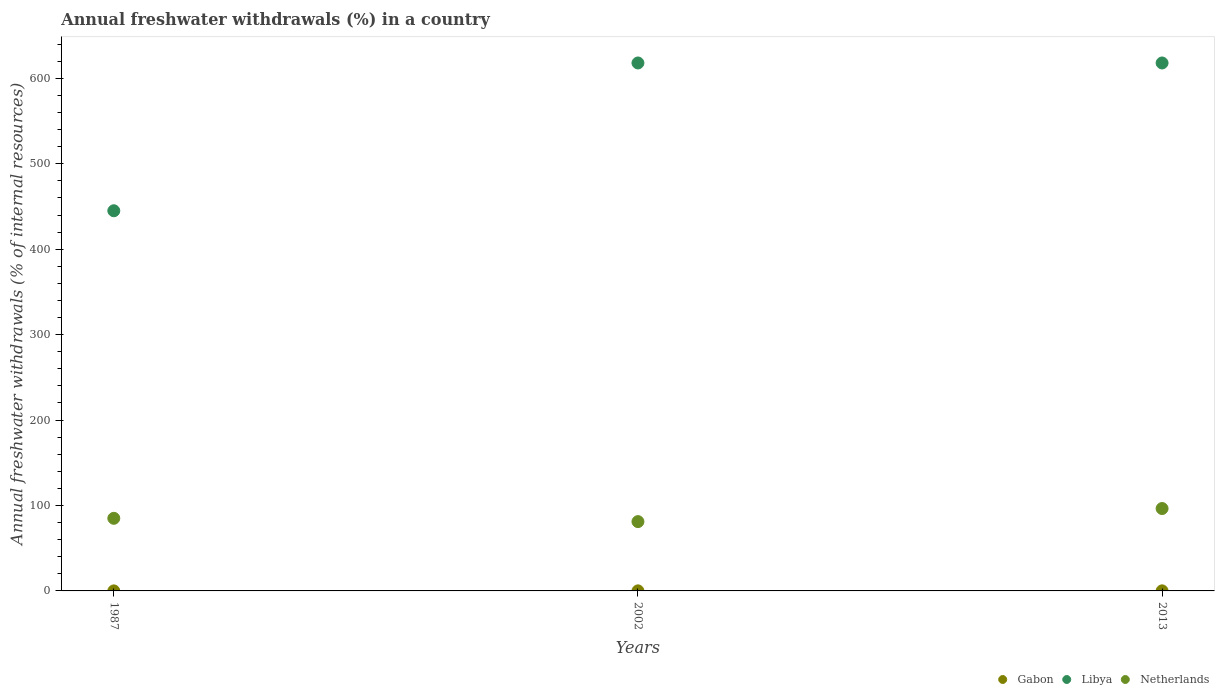Is the number of dotlines equal to the number of legend labels?
Your answer should be very brief. Yes. What is the percentage of annual freshwater withdrawals in Netherlands in 1987?
Keep it short and to the point. 84.99. Across all years, what is the maximum percentage of annual freshwater withdrawals in Libya?
Ensure brevity in your answer.  618. Across all years, what is the minimum percentage of annual freshwater withdrawals in Netherlands?
Ensure brevity in your answer.  81.13. What is the total percentage of annual freshwater withdrawals in Gabon in the graph?
Keep it short and to the point. 0.19. What is the difference between the percentage of annual freshwater withdrawals in Libya in 2013 and the percentage of annual freshwater withdrawals in Netherlands in 1987?
Provide a succinct answer. 533.01. What is the average percentage of annual freshwater withdrawals in Netherlands per year?
Offer a very short reply. 87.52. In the year 1987, what is the difference between the percentage of annual freshwater withdrawals in Gabon and percentage of annual freshwater withdrawals in Netherlands?
Your answer should be very brief. -84.95. What is the ratio of the percentage of annual freshwater withdrawals in Libya in 1987 to that in 2002?
Your answer should be compact. 0.72. What is the difference between the highest and the second highest percentage of annual freshwater withdrawals in Gabon?
Your response must be concise. 0.01. What is the difference between the highest and the lowest percentage of annual freshwater withdrawals in Netherlands?
Your answer should be very brief. 15.33. In how many years, is the percentage of annual freshwater withdrawals in Netherlands greater than the average percentage of annual freshwater withdrawals in Netherlands taken over all years?
Your response must be concise. 1. Is the sum of the percentage of annual freshwater withdrawals in Libya in 1987 and 2002 greater than the maximum percentage of annual freshwater withdrawals in Gabon across all years?
Keep it short and to the point. Yes. Is it the case that in every year, the sum of the percentage of annual freshwater withdrawals in Gabon and percentage of annual freshwater withdrawals in Netherlands  is greater than the percentage of annual freshwater withdrawals in Libya?
Give a very brief answer. No. Does the percentage of annual freshwater withdrawals in Netherlands monotonically increase over the years?
Your answer should be compact. No. How many dotlines are there?
Make the answer very short. 3. How many years are there in the graph?
Your response must be concise. 3. What is the difference between two consecutive major ticks on the Y-axis?
Your answer should be compact. 100. Does the graph contain any zero values?
Offer a terse response. No. Where does the legend appear in the graph?
Make the answer very short. Bottom right. How are the legend labels stacked?
Ensure brevity in your answer.  Horizontal. What is the title of the graph?
Provide a succinct answer. Annual freshwater withdrawals (%) in a country. What is the label or title of the X-axis?
Provide a short and direct response. Years. What is the label or title of the Y-axis?
Offer a terse response. Annual freshwater withdrawals (% of internal resources). What is the Annual freshwater withdrawals (% of internal resources) of Gabon in 1987?
Give a very brief answer. 0.04. What is the Annual freshwater withdrawals (% of internal resources) in Libya in 1987?
Your answer should be compact. 445. What is the Annual freshwater withdrawals (% of internal resources) in Netherlands in 1987?
Offer a very short reply. 84.99. What is the Annual freshwater withdrawals (% of internal resources) in Gabon in 2002?
Offer a very short reply. 0.07. What is the Annual freshwater withdrawals (% of internal resources) in Libya in 2002?
Ensure brevity in your answer.  618. What is the Annual freshwater withdrawals (% of internal resources) in Netherlands in 2002?
Keep it short and to the point. 81.13. What is the Annual freshwater withdrawals (% of internal resources) of Gabon in 2013?
Provide a succinct answer. 0.08. What is the Annual freshwater withdrawals (% of internal resources) in Libya in 2013?
Ensure brevity in your answer.  618. What is the Annual freshwater withdrawals (% of internal resources) of Netherlands in 2013?
Offer a very short reply. 96.45. Across all years, what is the maximum Annual freshwater withdrawals (% of internal resources) of Gabon?
Offer a terse response. 0.08. Across all years, what is the maximum Annual freshwater withdrawals (% of internal resources) of Libya?
Offer a very short reply. 618. Across all years, what is the maximum Annual freshwater withdrawals (% of internal resources) in Netherlands?
Offer a very short reply. 96.45. Across all years, what is the minimum Annual freshwater withdrawals (% of internal resources) of Gabon?
Make the answer very short. 0.04. Across all years, what is the minimum Annual freshwater withdrawals (% of internal resources) in Libya?
Offer a terse response. 445. Across all years, what is the minimum Annual freshwater withdrawals (% of internal resources) of Netherlands?
Provide a succinct answer. 81.13. What is the total Annual freshwater withdrawals (% of internal resources) in Gabon in the graph?
Offer a terse response. 0.19. What is the total Annual freshwater withdrawals (% of internal resources) of Libya in the graph?
Provide a short and direct response. 1681. What is the total Annual freshwater withdrawals (% of internal resources) of Netherlands in the graph?
Your answer should be compact. 262.57. What is the difference between the Annual freshwater withdrawals (% of internal resources) of Gabon in 1987 and that in 2002?
Provide a short and direct response. -0.04. What is the difference between the Annual freshwater withdrawals (% of internal resources) of Libya in 1987 and that in 2002?
Offer a very short reply. -173. What is the difference between the Annual freshwater withdrawals (% of internal resources) in Netherlands in 1987 and that in 2002?
Offer a terse response. 3.86. What is the difference between the Annual freshwater withdrawals (% of internal resources) of Gabon in 1987 and that in 2013?
Keep it short and to the point. -0.05. What is the difference between the Annual freshwater withdrawals (% of internal resources) of Libya in 1987 and that in 2013?
Offer a very short reply. -173. What is the difference between the Annual freshwater withdrawals (% of internal resources) of Netherlands in 1987 and that in 2013?
Offer a terse response. -11.46. What is the difference between the Annual freshwater withdrawals (% of internal resources) in Gabon in 2002 and that in 2013?
Offer a very short reply. -0.01. What is the difference between the Annual freshwater withdrawals (% of internal resources) of Libya in 2002 and that in 2013?
Keep it short and to the point. 0. What is the difference between the Annual freshwater withdrawals (% of internal resources) in Netherlands in 2002 and that in 2013?
Offer a terse response. -15.33. What is the difference between the Annual freshwater withdrawals (% of internal resources) of Gabon in 1987 and the Annual freshwater withdrawals (% of internal resources) of Libya in 2002?
Your answer should be compact. -617.96. What is the difference between the Annual freshwater withdrawals (% of internal resources) of Gabon in 1987 and the Annual freshwater withdrawals (% of internal resources) of Netherlands in 2002?
Your response must be concise. -81.09. What is the difference between the Annual freshwater withdrawals (% of internal resources) in Libya in 1987 and the Annual freshwater withdrawals (% of internal resources) in Netherlands in 2002?
Give a very brief answer. 363.87. What is the difference between the Annual freshwater withdrawals (% of internal resources) in Gabon in 1987 and the Annual freshwater withdrawals (% of internal resources) in Libya in 2013?
Your answer should be compact. -617.96. What is the difference between the Annual freshwater withdrawals (% of internal resources) in Gabon in 1987 and the Annual freshwater withdrawals (% of internal resources) in Netherlands in 2013?
Provide a short and direct response. -96.42. What is the difference between the Annual freshwater withdrawals (% of internal resources) in Libya in 1987 and the Annual freshwater withdrawals (% of internal resources) in Netherlands in 2013?
Keep it short and to the point. 348.55. What is the difference between the Annual freshwater withdrawals (% of internal resources) of Gabon in 2002 and the Annual freshwater withdrawals (% of internal resources) of Libya in 2013?
Provide a succinct answer. -617.93. What is the difference between the Annual freshwater withdrawals (% of internal resources) in Gabon in 2002 and the Annual freshwater withdrawals (% of internal resources) in Netherlands in 2013?
Offer a very short reply. -96.38. What is the difference between the Annual freshwater withdrawals (% of internal resources) of Libya in 2002 and the Annual freshwater withdrawals (% of internal resources) of Netherlands in 2013?
Your response must be concise. 521.55. What is the average Annual freshwater withdrawals (% of internal resources) in Gabon per year?
Provide a short and direct response. 0.06. What is the average Annual freshwater withdrawals (% of internal resources) in Libya per year?
Keep it short and to the point. 560.33. What is the average Annual freshwater withdrawals (% of internal resources) of Netherlands per year?
Offer a terse response. 87.52. In the year 1987, what is the difference between the Annual freshwater withdrawals (% of internal resources) in Gabon and Annual freshwater withdrawals (% of internal resources) in Libya?
Provide a succinct answer. -444.96. In the year 1987, what is the difference between the Annual freshwater withdrawals (% of internal resources) in Gabon and Annual freshwater withdrawals (% of internal resources) in Netherlands?
Offer a terse response. -84.95. In the year 1987, what is the difference between the Annual freshwater withdrawals (% of internal resources) in Libya and Annual freshwater withdrawals (% of internal resources) in Netherlands?
Offer a terse response. 360.01. In the year 2002, what is the difference between the Annual freshwater withdrawals (% of internal resources) of Gabon and Annual freshwater withdrawals (% of internal resources) of Libya?
Ensure brevity in your answer.  -617.93. In the year 2002, what is the difference between the Annual freshwater withdrawals (% of internal resources) of Gabon and Annual freshwater withdrawals (% of internal resources) of Netherlands?
Provide a succinct answer. -81.05. In the year 2002, what is the difference between the Annual freshwater withdrawals (% of internal resources) of Libya and Annual freshwater withdrawals (% of internal resources) of Netherlands?
Your answer should be compact. 536.87. In the year 2013, what is the difference between the Annual freshwater withdrawals (% of internal resources) of Gabon and Annual freshwater withdrawals (% of internal resources) of Libya?
Your response must be concise. -617.92. In the year 2013, what is the difference between the Annual freshwater withdrawals (% of internal resources) in Gabon and Annual freshwater withdrawals (% of internal resources) in Netherlands?
Your answer should be compact. -96.37. In the year 2013, what is the difference between the Annual freshwater withdrawals (% of internal resources) of Libya and Annual freshwater withdrawals (% of internal resources) of Netherlands?
Ensure brevity in your answer.  521.55. What is the ratio of the Annual freshwater withdrawals (% of internal resources) of Gabon in 1987 to that in 2002?
Your answer should be compact. 0.5. What is the ratio of the Annual freshwater withdrawals (% of internal resources) of Libya in 1987 to that in 2002?
Offer a very short reply. 0.72. What is the ratio of the Annual freshwater withdrawals (% of internal resources) in Netherlands in 1987 to that in 2002?
Your response must be concise. 1.05. What is the ratio of the Annual freshwater withdrawals (% of internal resources) in Gabon in 1987 to that in 2013?
Ensure brevity in your answer.  0.43. What is the ratio of the Annual freshwater withdrawals (% of internal resources) in Libya in 1987 to that in 2013?
Make the answer very short. 0.72. What is the ratio of the Annual freshwater withdrawals (% of internal resources) of Netherlands in 1987 to that in 2013?
Your response must be concise. 0.88. What is the ratio of the Annual freshwater withdrawals (% of internal resources) of Gabon in 2002 to that in 2013?
Provide a succinct answer. 0.86. What is the ratio of the Annual freshwater withdrawals (% of internal resources) of Libya in 2002 to that in 2013?
Ensure brevity in your answer.  1. What is the ratio of the Annual freshwater withdrawals (% of internal resources) in Netherlands in 2002 to that in 2013?
Offer a terse response. 0.84. What is the difference between the highest and the second highest Annual freshwater withdrawals (% of internal resources) of Gabon?
Give a very brief answer. 0.01. What is the difference between the highest and the second highest Annual freshwater withdrawals (% of internal resources) in Netherlands?
Provide a short and direct response. 11.46. What is the difference between the highest and the lowest Annual freshwater withdrawals (% of internal resources) in Gabon?
Provide a short and direct response. 0.05. What is the difference between the highest and the lowest Annual freshwater withdrawals (% of internal resources) of Libya?
Ensure brevity in your answer.  173. What is the difference between the highest and the lowest Annual freshwater withdrawals (% of internal resources) of Netherlands?
Provide a short and direct response. 15.33. 